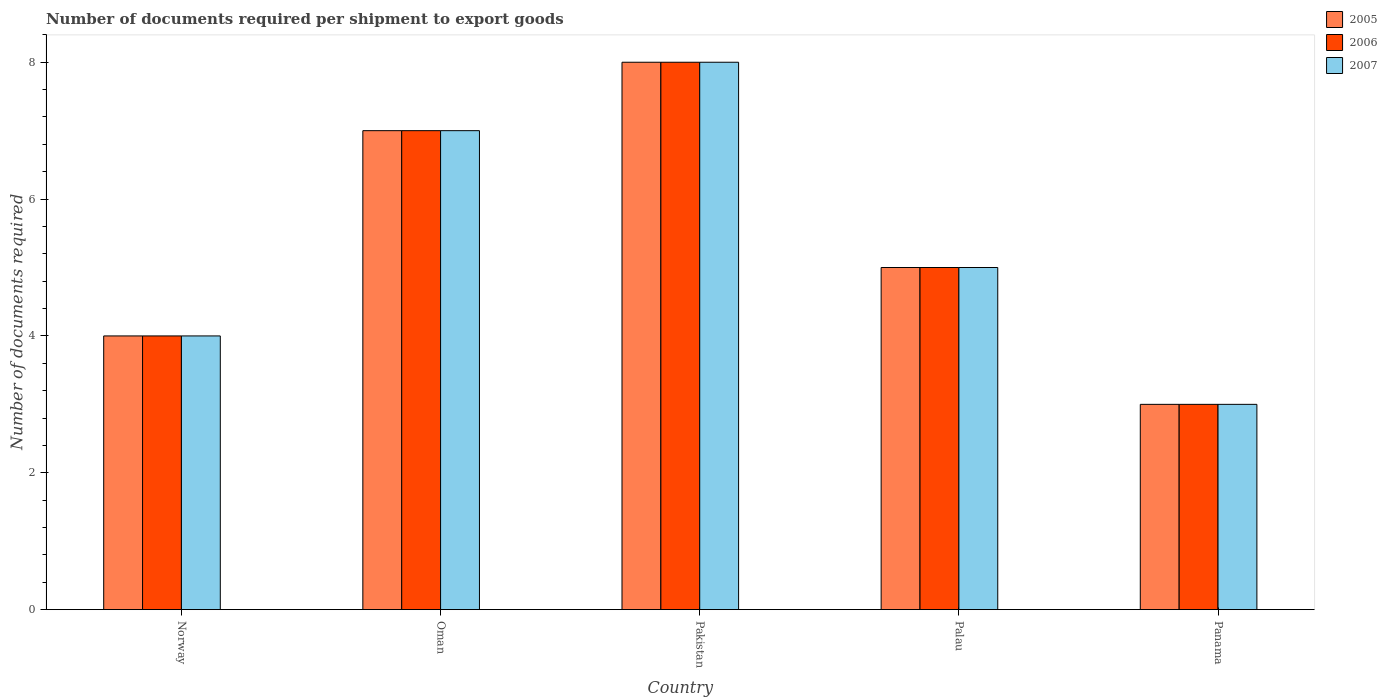How many groups of bars are there?
Ensure brevity in your answer.  5. Are the number of bars per tick equal to the number of legend labels?
Offer a terse response. Yes. How many bars are there on the 4th tick from the right?
Your answer should be compact. 3. What is the label of the 1st group of bars from the left?
Your answer should be very brief. Norway. Across all countries, what is the maximum number of documents required per shipment to export goods in 2007?
Your response must be concise. 8. In which country was the number of documents required per shipment to export goods in 2005 maximum?
Your response must be concise. Pakistan. In which country was the number of documents required per shipment to export goods in 2005 minimum?
Your answer should be compact. Panama. What is the total number of documents required per shipment to export goods in 2006 in the graph?
Your answer should be compact. 27. What is the difference between the number of documents required per shipment to export goods in 2005 in Norway and that in Pakistan?
Provide a short and direct response. -4. What is the ratio of the number of documents required per shipment to export goods in 2006 in Norway to that in Oman?
Give a very brief answer. 0.57. Is the number of documents required per shipment to export goods in 2007 in Norway less than that in Palau?
Ensure brevity in your answer.  Yes. What is the difference between the highest and the lowest number of documents required per shipment to export goods in 2006?
Your answer should be very brief. 5. In how many countries, is the number of documents required per shipment to export goods in 2006 greater than the average number of documents required per shipment to export goods in 2006 taken over all countries?
Provide a succinct answer. 2. Is the sum of the number of documents required per shipment to export goods in 2006 in Norway and Panama greater than the maximum number of documents required per shipment to export goods in 2007 across all countries?
Offer a terse response. No. What does the 1st bar from the left in Pakistan represents?
Ensure brevity in your answer.  2005. Is it the case that in every country, the sum of the number of documents required per shipment to export goods in 2005 and number of documents required per shipment to export goods in 2006 is greater than the number of documents required per shipment to export goods in 2007?
Keep it short and to the point. Yes. What is the difference between two consecutive major ticks on the Y-axis?
Offer a very short reply. 2. Does the graph contain any zero values?
Make the answer very short. No. How are the legend labels stacked?
Your answer should be compact. Vertical. What is the title of the graph?
Provide a short and direct response. Number of documents required per shipment to export goods. What is the label or title of the X-axis?
Ensure brevity in your answer.  Country. What is the label or title of the Y-axis?
Your response must be concise. Number of documents required. What is the Number of documents required in 2005 in Norway?
Provide a short and direct response. 4. What is the Number of documents required of 2005 in Oman?
Your answer should be compact. 7. What is the Number of documents required of 2006 in Oman?
Give a very brief answer. 7. What is the Number of documents required of 2007 in Oman?
Your response must be concise. 7. What is the Number of documents required of 2005 in Pakistan?
Offer a terse response. 8. What is the Number of documents required of 2007 in Pakistan?
Keep it short and to the point. 8. What is the Number of documents required of 2007 in Panama?
Offer a very short reply. 3. Across all countries, what is the maximum Number of documents required of 2006?
Make the answer very short. 8. Across all countries, what is the maximum Number of documents required in 2007?
Keep it short and to the point. 8. What is the total Number of documents required in 2005 in the graph?
Make the answer very short. 27. What is the total Number of documents required of 2006 in the graph?
Make the answer very short. 27. What is the difference between the Number of documents required of 2007 in Norway and that in Oman?
Your response must be concise. -3. What is the difference between the Number of documents required in 2005 in Norway and that in Pakistan?
Offer a terse response. -4. What is the difference between the Number of documents required of 2006 in Norway and that in Pakistan?
Ensure brevity in your answer.  -4. What is the difference between the Number of documents required of 2007 in Norway and that in Pakistan?
Your answer should be very brief. -4. What is the difference between the Number of documents required in 2005 in Norway and that in Palau?
Offer a terse response. -1. What is the difference between the Number of documents required in 2007 in Norway and that in Palau?
Provide a short and direct response. -1. What is the difference between the Number of documents required in 2005 in Norway and that in Panama?
Offer a terse response. 1. What is the difference between the Number of documents required in 2007 in Norway and that in Panama?
Provide a succinct answer. 1. What is the difference between the Number of documents required of 2006 in Oman and that in Palau?
Your answer should be compact. 2. What is the difference between the Number of documents required in 2006 in Oman and that in Panama?
Your answer should be compact. 4. What is the difference between the Number of documents required of 2006 in Pakistan and that in Palau?
Provide a succinct answer. 3. What is the difference between the Number of documents required in 2005 in Palau and that in Panama?
Your answer should be very brief. 2. What is the difference between the Number of documents required of 2007 in Palau and that in Panama?
Your answer should be compact. 2. What is the difference between the Number of documents required in 2005 in Norway and the Number of documents required in 2007 in Oman?
Offer a very short reply. -3. What is the difference between the Number of documents required in 2006 in Norway and the Number of documents required in 2007 in Oman?
Make the answer very short. -3. What is the difference between the Number of documents required of 2006 in Norway and the Number of documents required of 2007 in Pakistan?
Your answer should be compact. -4. What is the difference between the Number of documents required in 2005 in Norway and the Number of documents required in 2007 in Palau?
Provide a succinct answer. -1. What is the difference between the Number of documents required of 2006 in Norway and the Number of documents required of 2007 in Palau?
Offer a terse response. -1. What is the difference between the Number of documents required of 2005 in Norway and the Number of documents required of 2007 in Panama?
Your answer should be very brief. 1. What is the difference between the Number of documents required in 2006 in Norway and the Number of documents required in 2007 in Panama?
Make the answer very short. 1. What is the difference between the Number of documents required of 2005 in Oman and the Number of documents required of 2007 in Pakistan?
Keep it short and to the point. -1. What is the difference between the Number of documents required in 2005 in Oman and the Number of documents required in 2006 in Palau?
Ensure brevity in your answer.  2. What is the difference between the Number of documents required of 2005 in Oman and the Number of documents required of 2007 in Palau?
Your answer should be compact. 2. What is the difference between the Number of documents required of 2006 in Oman and the Number of documents required of 2007 in Panama?
Offer a terse response. 4. What is the difference between the Number of documents required in 2005 in Pakistan and the Number of documents required in 2007 in Palau?
Offer a terse response. 3. What is the difference between the Number of documents required of 2005 in Palau and the Number of documents required of 2007 in Panama?
Give a very brief answer. 2. What is the difference between the Number of documents required of 2006 in Palau and the Number of documents required of 2007 in Panama?
Offer a terse response. 2. What is the average Number of documents required of 2006 per country?
Your answer should be very brief. 5.4. What is the difference between the Number of documents required of 2005 and Number of documents required of 2006 in Norway?
Offer a very short reply. 0. What is the difference between the Number of documents required of 2006 and Number of documents required of 2007 in Norway?
Give a very brief answer. 0. What is the difference between the Number of documents required in 2006 and Number of documents required in 2007 in Oman?
Keep it short and to the point. 0. What is the difference between the Number of documents required of 2005 and Number of documents required of 2006 in Pakistan?
Your answer should be very brief. 0. What is the difference between the Number of documents required of 2005 and Number of documents required of 2007 in Pakistan?
Your response must be concise. 0. What is the difference between the Number of documents required of 2006 and Number of documents required of 2007 in Pakistan?
Offer a very short reply. 0. What is the difference between the Number of documents required of 2005 and Number of documents required of 2006 in Palau?
Give a very brief answer. 0. What is the difference between the Number of documents required of 2006 and Number of documents required of 2007 in Palau?
Give a very brief answer. 0. What is the difference between the Number of documents required in 2005 and Number of documents required in 2006 in Panama?
Provide a short and direct response. 0. What is the difference between the Number of documents required in 2005 and Number of documents required in 2007 in Panama?
Your response must be concise. 0. What is the difference between the Number of documents required of 2006 and Number of documents required of 2007 in Panama?
Provide a succinct answer. 0. What is the ratio of the Number of documents required in 2006 in Norway to that in Oman?
Offer a terse response. 0.57. What is the ratio of the Number of documents required in 2005 in Norway to that in Pakistan?
Offer a terse response. 0.5. What is the ratio of the Number of documents required of 2005 in Norway to that in Palau?
Your answer should be very brief. 0.8. What is the ratio of the Number of documents required of 2006 in Norway to that in Palau?
Give a very brief answer. 0.8. What is the ratio of the Number of documents required in 2005 in Norway to that in Panama?
Make the answer very short. 1.33. What is the ratio of the Number of documents required of 2007 in Norway to that in Panama?
Your answer should be very brief. 1.33. What is the ratio of the Number of documents required in 2005 in Oman to that in Pakistan?
Provide a short and direct response. 0.88. What is the ratio of the Number of documents required of 2006 in Oman to that in Pakistan?
Your response must be concise. 0.88. What is the ratio of the Number of documents required of 2007 in Oman to that in Pakistan?
Offer a very short reply. 0.88. What is the ratio of the Number of documents required of 2005 in Oman to that in Palau?
Provide a succinct answer. 1.4. What is the ratio of the Number of documents required of 2006 in Oman to that in Palau?
Offer a very short reply. 1.4. What is the ratio of the Number of documents required in 2005 in Oman to that in Panama?
Make the answer very short. 2.33. What is the ratio of the Number of documents required in 2006 in Oman to that in Panama?
Your response must be concise. 2.33. What is the ratio of the Number of documents required in 2007 in Oman to that in Panama?
Provide a short and direct response. 2.33. What is the ratio of the Number of documents required in 2006 in Pakistan to that in Palau?
Make the answer very short. 1.6. What is the ratio of the Number of documents required of 2007 in Pakistan to that in Palau?
Your response must be concise. 1.6. What is the ratio of the Number of documents required of 2005 in Pakistan to that in Panama?
Your answer should be compact. 2.67. What is the ratio of the Number of documents required in 2006 in Pakistan to that in Panama?
Your response must be concise. 2.67. What is the ratio of the Number of documents required in 2007 in Pakistan to that in Panama?
Offer a very short reply. 2.67. What is the ratio of the Number of documents required in 2005 in Palau to that in Panama?
Keep it short and to the point. 1.67. What is the ratio of the Number of documents required of 2007 in Palau to that in Panama?
Make the answer very short. 1.67. What is the difference between the highest and the second highest Number of documents required of 2006?
Your answer should be compact. 1. What is the difference between the highest and the second highest Number of documents required in 2007?
Offer a very short reply. 1. What is the difference between the highest and the lowest Number of documents required of 2006?
Your response must be concise. 5. 